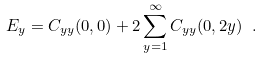Convert formula to latex. <formula><loc_0><loc_0><loc_500><loc_500>E _ { y } = C _ { y y } ( 0 , 0 ) + 2 \sum _ { y = 1 } ^ { \infty } C _ { y y } ( 0 , 2 y ) \ .</formula> 